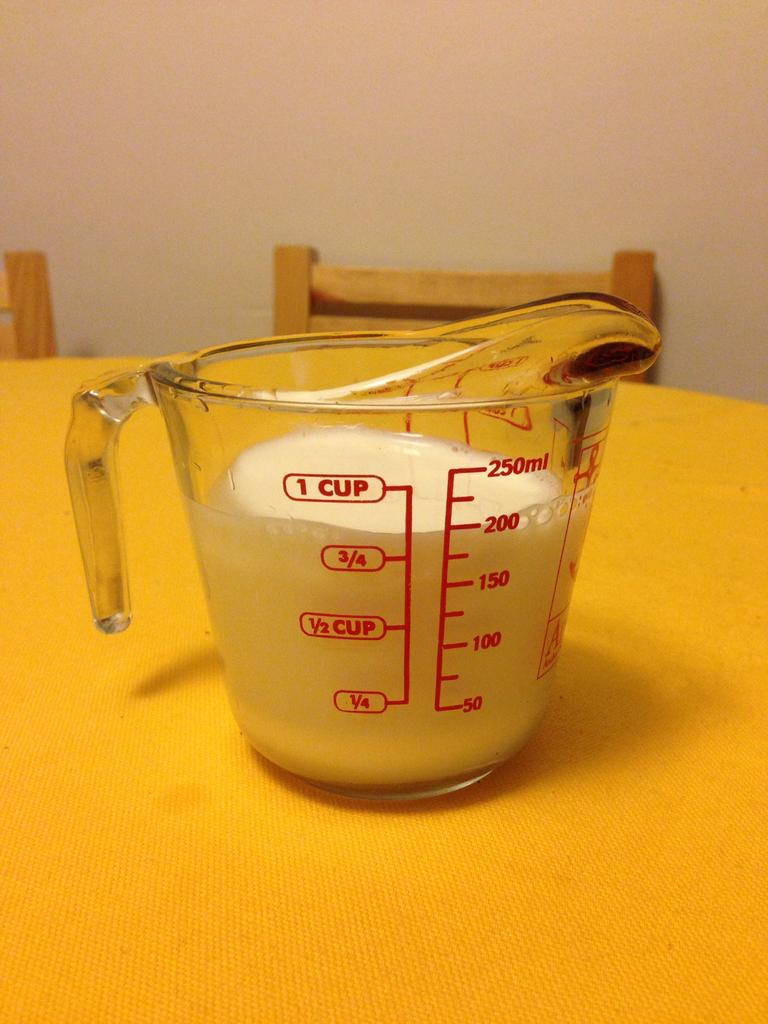Provide a one-sentence caption for the provided image. A measuring cup is filled to the 200 ml line with milk. 